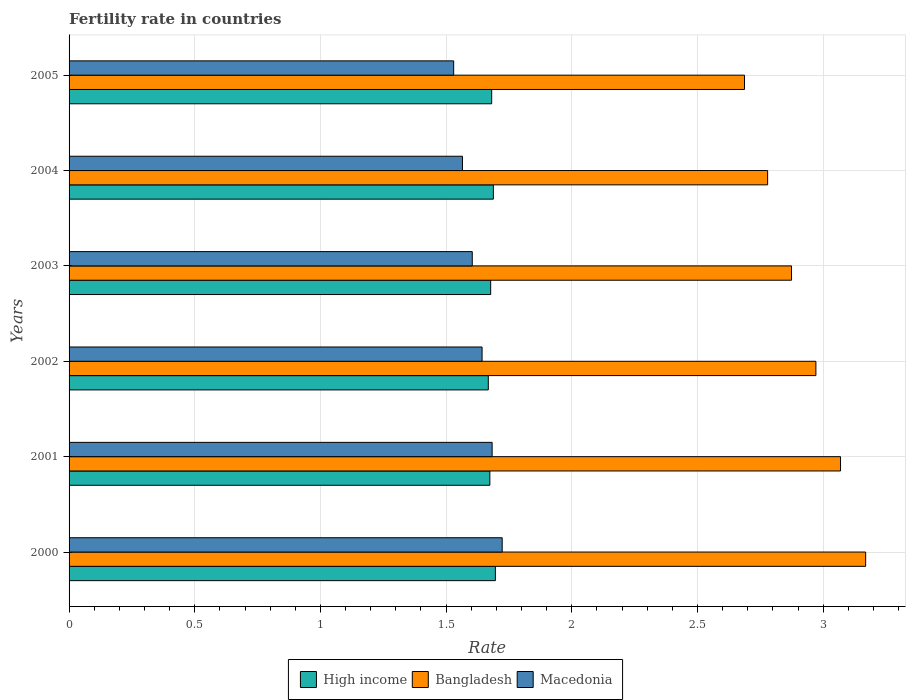Are the number of bars on each tick of the Y-axis equal?
Provide a succinct answer. Yes. In how many cases, is the number of bars for a given year not equal to the number of legend labels?
Ensure brevity in your answer.  0. What is the fertility rate in High income in 2003?
Offer a very short reply. 1.68. Across all years, what is the maximum fertility rate in High income?
Your answer should be very brief. 1.7. Across all years, what is the minimum fertility rate in Macedonia?
Your response must be concise. 1.53. In which year was the fertility rate in Bangladesh maximum?
Your answer should be compact. 2000. In which year was the fertility rate in Macedonia minimum?
Provide a succinct answer. 2005. What is the total fertility rate in Macedonia in the graph?
Offer a very short reply. 9.75. What is the difference between the fertility rate in High income in 2000 and that in 2004?
Offer a very short reply. 0.01. What is the difference between the fertility rate in High income in 2000 and the fertility rate in Macedonia in 2001?
Make the answer very short. 0.01. What is the average fertility rate in Macedonia per year?
Offer a very short reply. 1.62. In the year 2003, what is the difference between the fertility rate in Bangladesh and fertility rate in High income?
Offer a terse response. 1.2. What is the ratio of the fertility rate in Bangladesh in 2000 to that in 2001?
Make the answer very short. 1.03. Is the fertility rate in High income in 2000 less than that in 2003?
Provide a succinct answer. No. What is the difference between the highest and the second highest fertility rate in High income?
Ensure brevity in your answer.  0.01. What is the difference between the highest and the lowest fertility rate in Macedonia?
Your response must be concise. 0.19. In how many years, is the fertility rate in Macedonia greater than the average fertility rate in Macedonia taken over all years?
Offer a terse response. 3. Is the sum of the fertility rate in Bangladesh in 2000 and 2005 greater than the maximum fertility rate in Macedonia across all years?
Provide a succinct answer. Yes. What does the 1st bar from the bottom in 2002 represents?
Provide a succinct answer. High income. Is it the case that in every year, the sum of the fertility rate in Bangladesh and fertility rate in High income is greater than the fertility rate in Macedonia?
Offer a terse response. Yes. How many years are there in the graph?
Offer a terse response. 6. Does the graph contain any zero values?
Make the answer very short. No. Does the graph contain grids?
Keep it short and to the point. Yes. How many legend labels are there?
Offer a terse response. 3. How are the legend labels stacked?
Your response must be concise. Horizontal. What is the title of the graph?
Make the answer very short. Fertility rate in countries. Does "Bermuda" appear as one of the legend labels in the graph?
Ensure brevity in your answer.  No. What is the label or title of the X-axis?
Give a very brief answer. Rate. What is the Rate of High income in 2000?
Your answer should be very brief. 1.7. What is the Rate in Bangladesh in 2000?
Make the answer very short. 3.17. What is the Rate of Macedonia in 2000?
Your answer should be very brief. 1.72. What is the Rate of High income in 2001?
Provide a succinct answer. 1.67. What is the Rate in Bangladesh in 2001?
Ensure brevity in your answer.  3.07. What is the Rate in Macedonia in 2001?
Provide a short and direct response. 1.68. What is the Rate of High income in 2002?
Offer a very short reply. 1.67. What is the Rate in Bangladesh in 2002?
Provide a succinct answer. 2.97. What is the Rate in Macedonia in 2002?
Ensure brevity in your answer.  1.64. What is the Rate in High income in 2003?
Provide a short and direct response. 1.68. What is the Rate of Bangladesh in 2003?
Your answer should be compact. 2.87. What is the Rate of Macedonia in 2003?
Keep it short and to the point. 1.6. What is the Rate in High income in 2004?
Make the answer very short. 1.69. What is the Rate in Bangladesh in 2004?
Your answer should be compact. 2.78. What is the Rate of Macedonia in 2004?
Make the answer very short. 1.56. What is the Rate of High income in 2005?
Your answer should be very brief. 1.68. What is the Rate of Bangladesh in 2005?
Offer a terse response. 2.69. What is the Rate in Macedonia in 2005?
Keep it short and to the point. 1.53. Across all years, what is the maximum Rate in High income?
Your response must be concise. 1.7. Across all years, what is the maximum Rate of Bangladesh?
Offer a terse response. 3.17. Across all years, what is the maximum Rate of Macedonia?
Provide a succinct answer. 1.72. Across all years, what is the minimum Rate of High income?
Provide a succinct answer. 1.67. Across all years, what is the minimum Rate in Bangladesh?
Offer a very short reply. 2.69. Across all years, what is the minimum Rate of Macedonia?
Offer a very short reply. 1.53. What is the total Rate in High income in the graph?
Ensure brevity in your answer.  10.08. What is the total Rate in Bangladesh in the graph?
Ensure brevity in your answer.  17.55. What is the total Rate of Macedonia in the graph?
Give a very brief answer. 9.75. What is the difference between the Rate in High income in 2000 and that in 2001?
Ensure brevity in your answer.  0.02. What is the difference between the Rate of Macedonia in 2000 and that in 2001?
Offer a very short reply. 0.04. What is the difference between the Rate in High income in 2000 and that in 2002?
Your response must be concise. 0.03. What is the difference between the Rate in Bangladesh in 2000 and that in 2002?
Your response must be concise. 0.2. What is the difference between the Rate of Macedonia in 2000 and that in 2002?
Ensure brevity in your answer.  0.08. What is the difference between the Rate in High income in 2000 and that in 2003?
Your answer should be very brief. 0.02. What is the difference between the Rate of Bangladesh in 2000 and that in 2003?
Offer a very short reply. 0.29. What is the difference between the Rate in Macedonia in 2000 and that in 2003?
Keep it short and to the point. 0.12. What is the difference between the Rate in High income in 2000 and that in 2004?
Your answer should be very brief. 0.01. What is the difference between the Rate in Bangladesh in 2000 and that in 2004?
Make the answer very short. 0.39. What is the difference between the Rate of Macedonia in 2000 and that in 2004?
Offer a terse response. 0.16. What is the difference between the Rate in High income in 2000 and that in 2005?
Ensure brevity in your answer.  0.01. What is the difference between the Rate of Bangladesh in 2000 and that in 2005?
Provide a short and direct response. 0.48. What is the difference between the Rate of Macedonia in 2000 and that in 2005?
Your answer should be very brief. 0.19. What is the difference between the Rate in High income in 2001 and that in 2002?
Ensure brevity in your answer.  0.01. What is the difference between the Rate of Bangladesh in 2001 and that in 2002?
Offer a terse response. 0.1. What is the difference between the Rate of Macedonia in 2001 and that in 2002?
Ensure brevity in your answer.  0.04. What is the difference between the Rate in High income in 2001 and that in 2003?
Provide a succinct answer. -0. What is the difference between the Rate in Bangladesh in 2001 and that in 2003?
Your response must be concise. 0.2. What is the difference between the Rate of Macedonia in 2001 and that in 2003?
Your response must be concise. 0.08. What is the difference between the Rate in High income in 2001 and that in 2004?
Your answer should be compact. -0.01. What is the difference between the Rate in Bangladesh in 2001 and that in 2004?
Your answer should be very brief. 0.29. What is the difference between the Rate of Macedonia in 2001 and that in 2004?
Offer a terse response. 0.12. What is the difference between the Rate of High income in 2001 and that in 2005?
Your response must be concise. -0.01. What is the difference between the Rate of Bangladesh in 2001 and that in 2005?
Make the answer very short. 0.38. What is the difference between the Rate in Macedonia in 2001 and that in 2005?
Provide a succinct answer. 0.15. What is the difference between the Rate in High income in 2002 and that in 2003?
Give a very brief answer. -0.01. What is the difference between the Rate of Bangladesh in 2002 and that in 2003?
Your response must be concise. 0.1. What is the difference between the Rate of Macedonia in 2002 and that in 2003?
Ensure brevity in your answer.  0.04. What is the difference between the Rate in High income in 2002 and that in 2004?
Your response must be concise. -0.02. What is the difference between the Rate of Bangladesh in 2002 and that in 2004?
Make the answer very short. 0.19. What is the difference between the Rate in Macedonia in 2002 and that in 2004?
Offer a very short reply. 0.08. What is the difference between the Rate of High income in 2002 and that in 2005?
Provide a short and direct response. -0.01. What is the difference between the Rate in Bangladesh in 2002 and that in 2005?
Keep it short and to the point. 0.28. What is the difference between the Rate in Macedonia in 2002 and that in 2005?
Provide a short and direct response. 0.11. What is the difference between the Rate of High income in 2003 and that in 2004?
Give a very brief answer. -0.01. What is the difference between the Rate of Bangladesh in 2003 and that in 2004?
Your response must be concise. 0.1. What is the difference between the Rate of Macedonia in 2003 and that in 2004?
Make the answer very short. 0.04. What is the difference between the Rate of High income in 2003 and that in 2005?
Your response must be concise. -0. What is the difference between the Rate in Bangladesh in 2003 and that in 2005?
Ensure brevity in your answer.  0.19. What is the difference between the Rate of Macedonia in 2003 and that in 2005?
Make the answer very short. 0.07. What is the difference between the Rate in High income in 2004 and that in 2005?
Provide a succinct answer. 0.01. What is the difference between the Rate in Bangladesh in 2004 and that in 2005?
Offer a very short reply. 0.09. What is the difference between the Rate of Macedonia in 2004 and that in 2005?
Your answer should be compact. 0.04. What is the difference between the Rate in High income in 2000 and the Rate in Bangladesh in 2001?
Your answer should be compact. -1.37. What is the difference between the Rate in High income in 2000 and the Rate in Macedonia in 2001?
Your answer should be compact. 0.01. What is the difference between the Rate in Bangladesh in 2000 and the Rate in Macedonia in 2001?
Offer a very short reply. 1.49. What is the difference between the Rate in High income in 2000 and the Rate in Bangladesh in 2002?
Offer a very short reply. -1.27. What is the difference between the Rate of High income in 2000 and the Rate of Macedonia in 2002?
Offer a very short reply. 0.05. What is the difference between the Rate in Bangladesh in 2000 and the Rate in Macedonia in 2002?
Your answer should be very brief. 1.53. What is the difference between the Rate of High income in 2000 and the Rate of Bangladesh in 2003?
Your response must be concise. -1.18. What is the difference between the Rate in High income in 2000 and the Rate in Macedonia in 2003?
Ensure brevity in your answer.  0.09. What is the difference between the Rate in Bangladesh in 2000 and the Rate in Macedonia in 2003?
Give a very brief answer. 1.56. What is the difference between the Rate in High income in 2000 and the Rate in Bangladesh in 2004?
Ensure brevity in your answer.  -1.08. What is the difference between the Rate of High income in 2000 and the Rate of Macedonia in 2004?
Your response must be concise. 0.13. What is the difference between the Rate in Bangladesh in 2000 and the Rate in Macedonia in 2004?
Your answer should be very brief. 1.6. What is the difference between the Rate of High income in 2000 and the Rate of Bangladesh in 2005?
Offer a terse response. -0.99. What is the difference between the Rate of High income in 2000 and the Rate of Macedonia in 2005?
Your answer should be compact. 0.17. What is the difference between the Rate in Bangladesh in 2000 and the Rate in Macedonia in 2005?
Offer a very short reply. 1.64. What is the difference between the Rate of High income in 2001 and the Rate of Bangladesh in 2002?
Give a very brief answer. -1.3. What is the difference between the Rate of High income in 2001 and the Rate of Macedonia in 2002?
Keep it short and to the point. 0.03. What is the difference between the Rate in Bangladesh in 2001 and the Rate in Macedonia in 2002?
Give a very brief answer. 1.43. What is the difference between the Rate of High income in 2001 and the Rate of Bangladesh in 2003?
Provide a short and direct response. -1.2. What is the difference between the Rate of High income in 2001 and the Rate of Macedonia in 2003?
Provide a succinct answer. 0.07. What is the difference between the Rate in Bangladesh in 2001 and the Rate in Macedonia in 2003?
Your answer should be compact. 1.47. What is the difference between the Rate in High income in 2001 and the Rate in Bangladesh in 2004?
Your answer should be very brief. -1.11. What is the difference between the Rate in High income in 2001 and the Rate in Macedonia in 2004?
Provide a succinct answer. 0.11. What is the difference between the Rate of Bangladesh in 2001 and the Rate of Macedonia in 2004?
Your answer should be very brief. 1.5. What is the difference between the Rate of High income in 2001 and the Rate of Bangladesh in 2005?
Offer a terse response. -1.01. What is the difference between the Rate in High income in 2001 and the Rate in Macedonia in 2005?
Offer a very short reply. 0.14. What is the difference between the Rate in Bangladesh in 2001 and the Rate in Macedonia in 2005?
Give a very brief answer. 1.54. What is the difference between the Rate of High income in 2002 and the Rate of Bangladesh in 2003?
Your response must be concise. -1.21. What is the difference between the Rate of High income in 2002 and the Rate of Macedonia in 2003?
Your response must be concise. 0.06. What is the difference between the Rate in Bangladesh in 2002 and the Rate in Macedonia in 2003?
Offer a very short reply. 1.37. What is the difference between the Rate of High income in 2002 and the Rate of Bangladesh in 2004?
Make the answer very short. -1.11. What is the difference between the Rate in High income in 2002 and the Rate in Macedonia in 2004?
Offer a very short reply. 0.1. What is the difference between the Rate in Bangladesh in 2002 and the Rate in Macedonia in 2004?
Your response must be concise. 1.41. What is the difference between the Rate in High income in 2002 and the Rate in Bangladesh in 2005?
Make the answer very short. -1.02. What is the difference between the Rate in High income in 2002 and the Rate in Macedonia in 2005?
Your answer should be compact. 0.14. What is the difference between the Rate of Bangladesh in 2002 and the Rate of Macedonia in 2005?
Make the answer very short. 1.44. What is the difference between the Rate in High income in 2003 and the Rate in Bangladesh in 2004?
Ensure brevity in your answer.  -1.1. What is the difference between the Rate of High income in 2003 and the Rate of Macedonia in 2004?
Your answer should be very brief. 0.11. What is the difference between the Rate in Bangladesh in 2003 and the Rate in Macedonia in 2004?
Your response must be concise. 1.31. What is the difference between the Rate of High income in 2003 and the Rate of Bangladesh in 2005?
Offer a terse response. -1.01. What is the difference between the Rate in High income in 2003 and the Rate in Macedonia in 2005?
Offer a terse response. 0.15. What is the difference between the Rate in Bangladesh in 2003 and the Rate in Macedonia in 2005?
Make the answer very short. 1.34. What is the difference between the Rate of High income in 2004 and the Rate of Bangladesh in 2005?
Your answer should be compact. -1. What is the difference between the Rate of High income in 2004 and the Rate of Macedonia in 2005?
Make the answer very short. 0.16. What is the difference between the Rate of Bangladesh in 2004 and the Rate of Macedonia in 2005?
Give a very brief answer. 1.25. What is the average Rate of High income per year?
Your answer should be compact. 1.68. What is the average Rate of Bangladesh per year?
Provide a succinct answer. 2.92. What is the average Rate of Macedonia per year?
Your answer should be very brief. 1.62. In the year 2000, what is the difference between the Rate of High income and Rate of Bangladesh?
Make the answer very short. -1.47. In the year 2000, what is the difference between the Rate of High income and Rate of Macedonia?
Keep it short and to the point. -0.03. In the year 2000, what is the difference between the Rate in Bangladesh and Rate in Macedonia?
Your response must be concise. 1.45. In the year 2001, what is the difference between the Rate in High income and Rate in Bangladesh?
Ensure brevity in your answer.  -1.4. In the year 2001, what is the difference between the Rate in High income and Rate in Macedonia?
Give a very brief answer. -0.01. In the year 2001, what is the difference between the Rate in Bangladesh and Rate in Macedonia?
Ensure brevity in your answer.  1.39. In the year 2002, what is the difference between the Rate of High income and Rate of Bangladesh?
Give a very brief answer. -1.3. In the year 2002, what is the difference between the Rate in High income and Rate in Macedonia?
Provide a succinct answer. 0.02. In the year 2002, what is the difference between the Rate in Bangladesh and Rate in Macedonia?
Your answer should be compact. 1.33. In the year 2003, what is the difference between the Rate of High income and Rate of Bangladesh?
Provide a succinct answer. -1.2. In the year 2003, what is the difference between the Rate in High income and Rate in Macedonia?
Your answer should be compact. 0.07. In the year 2003, what is the difference between the Rate in Bangladesh and Rate in Macedonia?
Provide a succinct answer. 1.27. In the year 2004, what is the difference between the Rate in High income and Rate in Bangladesh?
Offer a terse response. -1.09. In the year 2004, what is the difference between the Rate in High income and Rate in Macedonia?
Offer a terse response. 0.12. In the year 2004, what is the difference between the Rate of Bangladesh and Rate of Macedonia?
Provide a succinct answer. 1.21. In the year 2005, what is the difference between the Rate in High income and Rate in Bangladesh?
Ensure brevity in your answer.  -1.01. In the year 2005, what is the difference between the Rate of High income and Rate of Macedonia?
Your response must be concise. 0.15. In the year 2005, what is the difference between the Rate of Bangladesh and Rate of Macedonia?
Your answer should be very brief. 1.16. What is the ratio of the Rate of High income in 2000 to that in 2001?
Make the answer very short. 1.01. What is the ratio of the Rate of Bangladesh in 2000 to that in 2001?
Offer a very short reply. 1.03. What is the ratio of the Rate of Macedonia in 2000 to that in 2001?
Keep it short and to the point. 1.02. What is the ratio of the Rate in High income in 2000 to that in 2002?
Provide a short and direct response. 1.02. What is the ratio of the Rate of Bangladesh in 2000 to that in 2002?
Offer a terse response. 1.07. What is the ratio of the Rate in Macedonia in 2000 to that in 2002?
Provide a succinct answer. 1.05. What is the ratio of the Rate of High income in 2000 to that in 2003?
Give a very brief answer. 1.01. What is the ratio of the Rate in Bangladesh in 2000 to that in 2003?
Offer a terse response. 1.1. What is the ratio of the Rate in Macedonia in 2000 to that in 2003?
Offer a very short reply. 1.07. What is the ratio of the Rate in Bangladesh in 2000 to that in 2004?
Ensure brevity in your answer.  1.14. What is the ratio of the Rate of Macedonia in 2000 to that in 2004?
Keep it short and to the point. 1.1. What is the ratio of the Rate in High income in 2000 to that in 2005?
Ensure brevity in your answer.  1.01. What is the ratio of the Rate of Bangladesh in 2000 to that in 2005?
Provide a succinct answer. 1.18. What is the ratio of the Rate in Macedonia in 2000 to that in 2005?
Your answer should be very brief. 1.13. What is the ratio of the Rate in High income in 2001 to that in 2002?
Your response must be concise. 1. What is the ratio of the Rate of Bangladesh in 2001 to that in 2002?
Keep it short and to the point. 1.03. What is the ratio of the Rate in Macedonia in 2001 to that in 2002?
Your answer should be compact. 1.02. What is the ratio of the Rate in High income in 2001 to that in 2003?
Give a very brief answer. 1. What is the ratio of the Rate of Bangladesh in 2001 to that in 2003?
Your answer should be compact. 1.07. What is the ratio of the Rate in Macedonia in 2001 to that in 2003?
Provide a succinct answer. 1.05. What is the ratio of the Rate in Bangladesh in 2001 to that in 2004?
Offer a very short reply. 1.1. What is the ratio of the Rate of Macedonia in 2001 to that in 2004?
Make the answer very short. 1.08. What is the ratio of the Rate in Bangladesh in 2001 to that in 2005?
Offer a terse response. 1.14. What is the ratio of the Rate in High income in 2002 to that in 2003?
Your answer should be very brief. 0.99. What is the ratio of the Rate of Bangladesh in 2002 to that in 2003?
Provide a short and direct response. 1.03. What is the ratio of the Rate in Macedonia in 2002 to that in 2003?
Your answer should be compact. 1.02. What is the ratio of the Rate in High income in 2002 to that in 2004?
Your answer should be very brief. 0.99. What is the ratio of the Rate in Bangladesh in 2002 to that in 2004?
Ensure brevity in your answer.  1.07. What is the ratio of the Rate in Macedonia in 2002 to that in 2004?
Your answer should be very brief. 1.05. What is the ratio of the Rate of High income in 2002 to that in 2005?
Give a very brief answer. 0.99. What is the ratio of the Rate in Bangladesh in 2002 to that in 2005?
Make the answer very short. 1.11. What is the ratio of the Rate in Macedonia in 2002 to that in 2005?
Your response must be concise. 1.07. What is the ratio of the Rate of Bangladesh in 2003 to that in 2004?
Your answer should be very brief. 1.03. What is the ratio of the Rate in Macedonia in 2003 to that in 2004?
Provide a short and direct response. 1.02. What is the ratio of the Rate of High income in 2003 to that in 2005?
Your response must be concise. 1. What is the ratio of the Rate of Bangladesh in 2003 to that in 2005?
Your answer should be very brief. 1.07. What is the ratio of the Rate of Macedonia in 2003 to that in 2005?
Offer a very short reply. 1.05. What is the ratio of the Rate in Bangladesh in 2004 to that in 2005?
Your answer should be compact. 1.03. What is the ratio of the Rate of Macedonia in 2004 to that in 2005?
Offer a terse response. 1.02. What is the difference between the highest and the second highest Rate of High income?
Provide a short and direct response. 0.01. What is the difference between the highest and the second highest Rate in Bangladesh?
Keep it short and to the point. 0.1. What is the difference between the highest and the lowest Rate of High income?
Make the answer very short. 0.03. What is the difference between the highest and the lowest Rate in Bangladesh?
Ensure brevity in your answer.  0.48. What is the difference between the highest and the lowest Rate in Macedonia?
Your answer should be very brief. 0.19. 